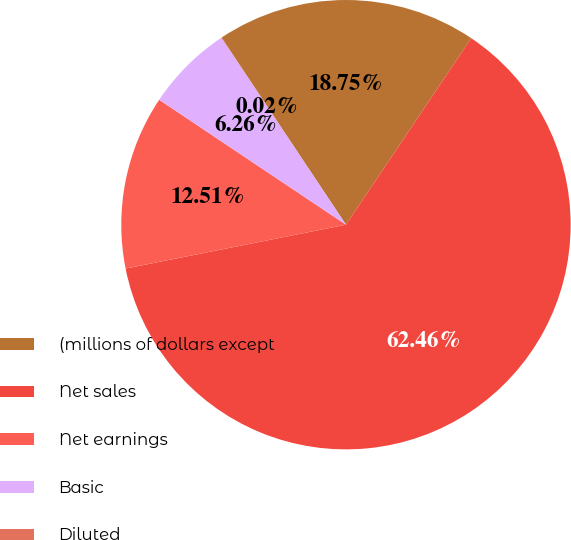<chart> <loc_0><loc_0><loc_500><loc_500><pie_chart><fcel>(millions of dollars except<fcel>Net sales<fcel>Net earnings<fcel>Basic<fcel>Diluted<nl><fcel>18.75%<fcel>62.46%<fcel>12.51%<fcel>6.26%<fcel>0.02%<nl></chart> 